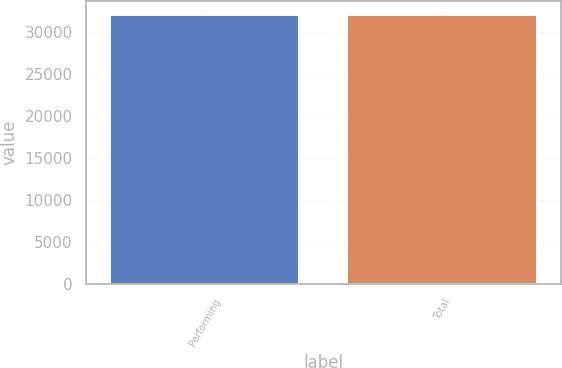Convert chart to OTSL. <chart><loc_0><loc_0><loc_500><loc_500><bar_chart><fcel>Performing<fcel>Total<nl><fcel>31996<fcel>32000<nl></chart> 